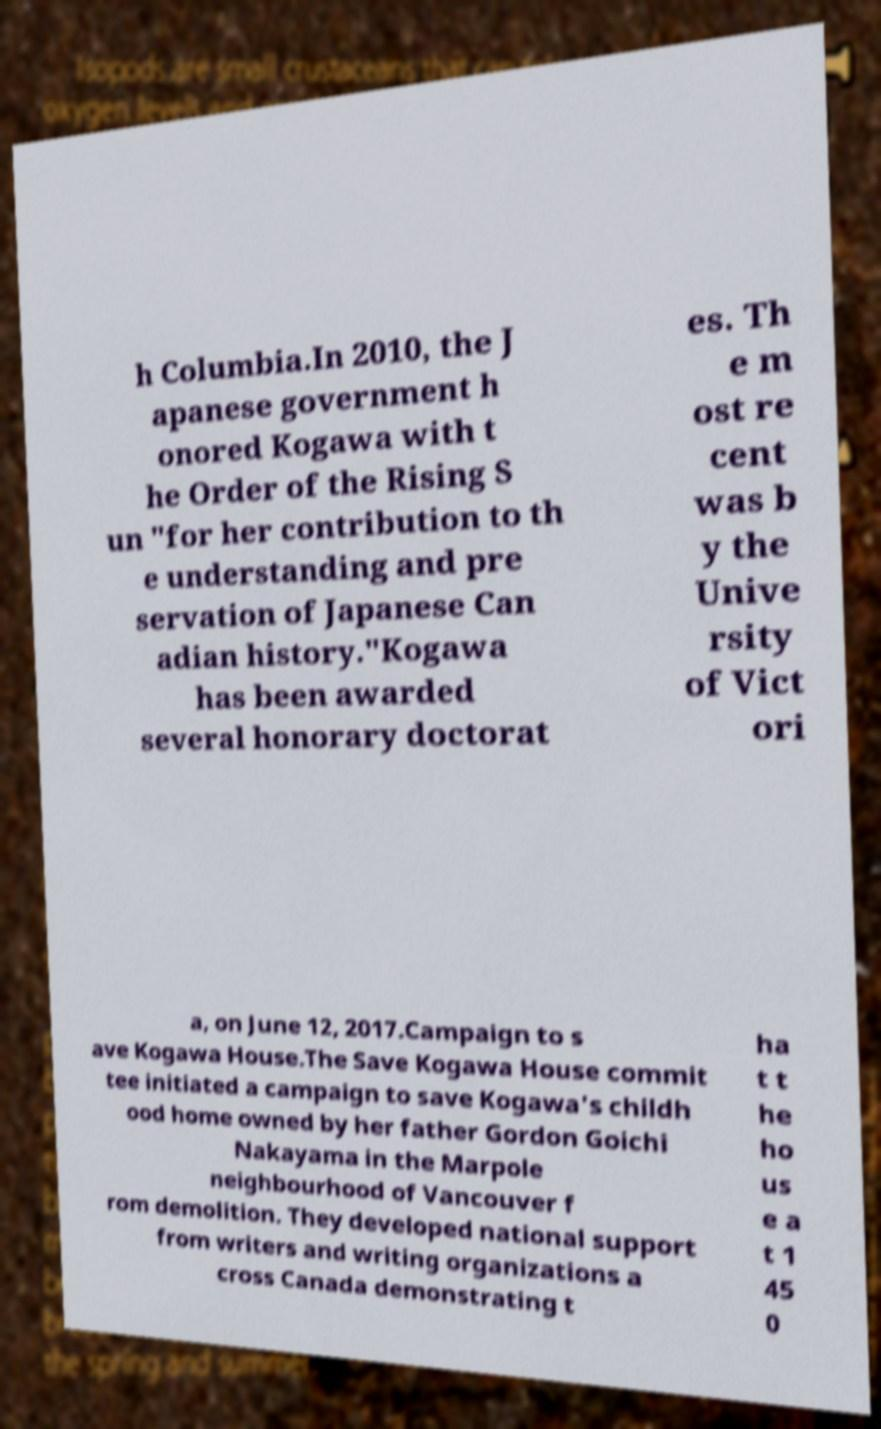Can you accurately transcribe the text from the provided image for me? h Columbia.In 2010, the J apanese government h onored Kogawa with t he Order of the Rising S un "for her contribution to th e understanding and pre servation of Japanese Can adian history."Kogawa has been awarded several honorary doctorat es. Th e m ost re cent was b y the Unive rsity of Vict ori a, on June 12, 2017.Campaign to s ave Kogawa House.The Save Kogawa House commit tee initiated a campaign to save Kogawa's childh ood home owned by her father Gordon Goichi Nakayama in the Marpole neighbourhood of Vancouver f rom demolition. They developed national support from writers and writing organizations a cross Canada demonstrating t ha t t he ho us e a t 1 45 0 